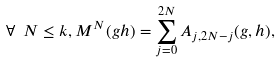Convert formula to latex. <formula><loc_0><loc_0><loc_500><loc_500>\forall \ N \leq k , M ^ { N } ( g h ) = \sum ^ { 2 N } _ { j = 0 } A _ { j , 2 N - j } ( g , h ) ,</formula> 